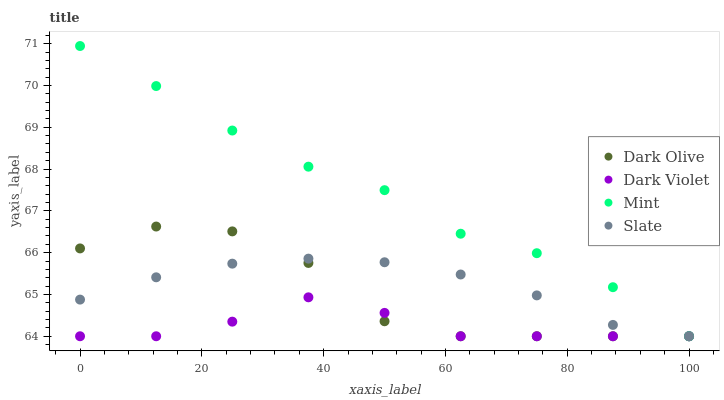Does Dark Violet have the minimum area under the curve?
Answer yes or no. Yes. Does Mint have the maximum area under the curve?
Answer yes or no. Yes. Does Dark Olive have the minimum area under the curve?
Answer yes or no. No. Does Dark Olive have the maximum area under the curve?
Answer yes or no. No. Is Slate the smoothest?
Answer yes or no. Yes. Is Dark Olive the roughest?
Answer yes or no. Yes. Is Mint the smoothest?
Answer yes or no. No. Is Mint the roughest?
Answer yes or no. No. Does Slate have the lowest value?
Answer yes or no. Yes. Does Mint have the highest value?
Answer yes or no. Yes. Does Dark Olive have the highest value?
Answer yes or no. No. Does Slate intersect Mint?
Answer yes or no. Yes. Is Slate less than Mint?
Answer yes or no. No. Is Slate greater than Mint?
Answer yes or no. No. 